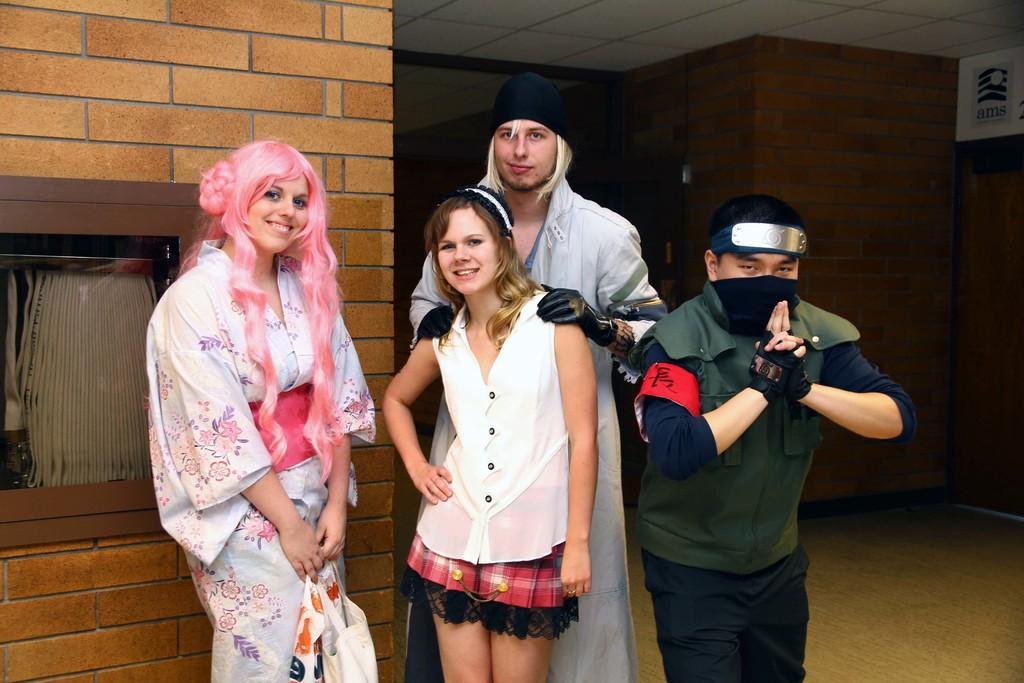Describe this image in one or two sentences. In the foreground of this picture, there are two men and two woman standing and having smile on their faces giving pose to a camera. In the background, there is a brown wall. 